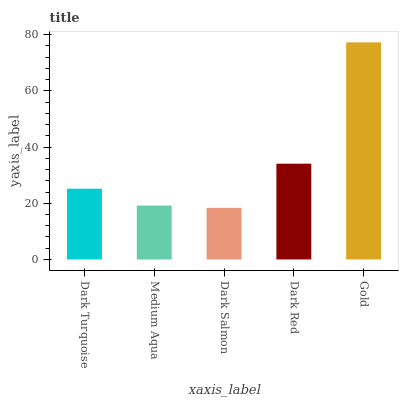Is Medium Aqua the minimum?
Answer yes or no. No. Is Medium Aqua the maximum?
Answer yes or no. No. Is Dark Turquoise greater than Medium Aqua?
Answer yes or no. Yes. Is Medium Aqua less than Dark Turquoise?
Answer yes or no. Yes. Is Medium Aqua greater than Dark Turquoise?
Answer yes or no. No. Is Dark Turquoise less than Medium Aqua?
Answer yes or no. No. Is Dark Turquoise the high median?
Answer yes or no. Yes. Is Dark Turquoise the low median?
Answer yes or no. Yes. Is Medium Aqua the high median?
Answer yes or no. No. Is Dark Salmon the low median?
Answer yes or no. No. 